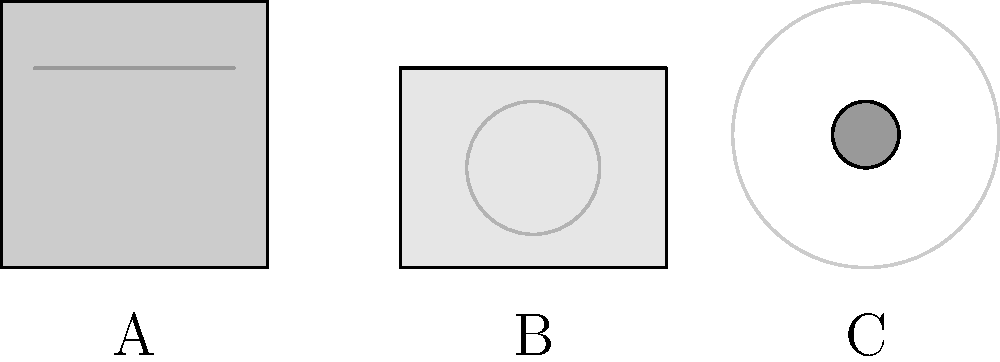As a retired tech executive with a unique collection of early tech industry documents, you're familiar with various storage media. In the image above, three types of storage media are represented schematically. Which of these (A, B, or C) represents the storage medium with the highest typical capacity in the early days of personal computing? To answer this question, let's analyze each storage medium represented in the image:

1. A: This schematic represents a floppy disk. Floppy disks were common in early personal computing but had limited storage capacity. Typical capacities ranged from 360 KB to 1.44 MB for the most common 3.5-inch disks.

2. B: This schematic represents a hard drive. Hard drives became increasingly common in personal computers in the late 1980s and early 1990s. They offered significantly higher storage capacities compared to floppy disks, typically ranging from 10 MB to several hundred MB in the early days of personal computing.

3. C: This schematic represents a tape reel. Tape storage was commonly used for data backup and archiving in early computing environments. While tape reels could store large amounts of data (often several gigabytes), they were not typically used as primary storage in personal computers due to their sequential access nature and slower read/write speeds.

Among these options, the hard drive (B) generally offered the highest practical storage capacity for personal computing in its early days. While tape reels could potentially store more data, they were not commonly used as primary storage in personal computers.

Therefore, the storage medium with the highest typical capacity in the early days of personal computing, as represented in the image, is B (the hard drive).
Answer: B 